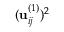Convert formula to latex. <formula><loc_0><loc_0><loc_500><loc_500>( u _ { i j } ^ { ( 1 ) } ) ^ { 2 }</formula> 